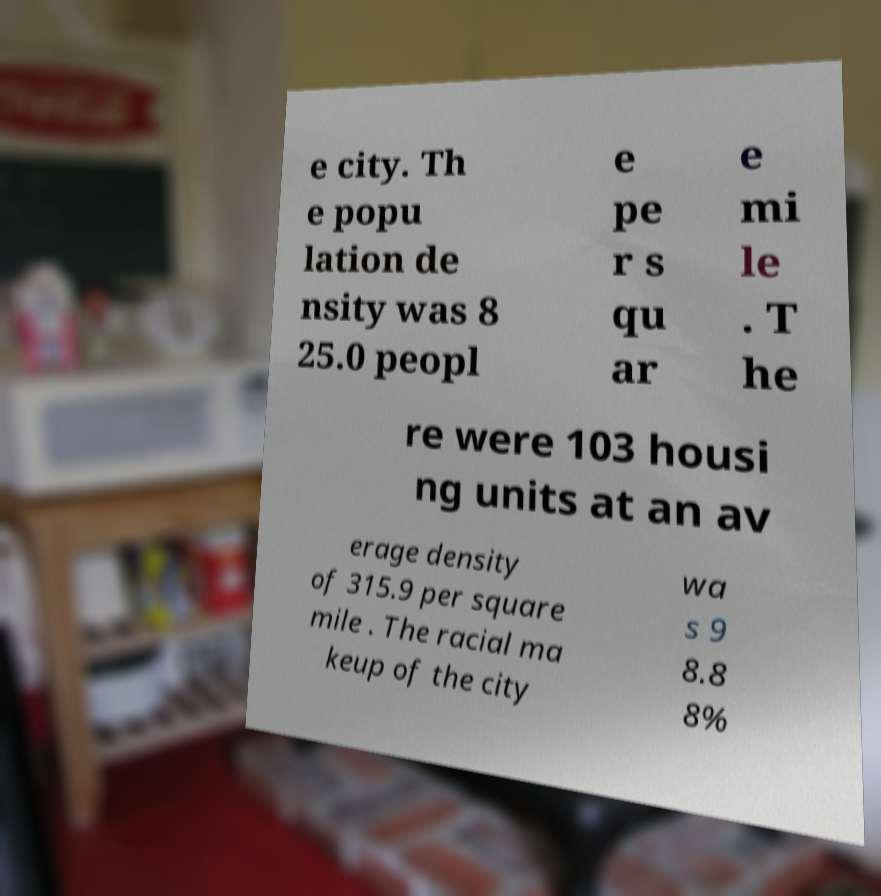Could you extract and type out the text from this image? e city. Th e popu lation de nsity was 8 25.0 peopl e pe r s qu ar e mi le . T he re were 103 housi ng units at an av erage density of 315.9 per square mile . The racial ma keup of the city wa s 9 8.8 8% 